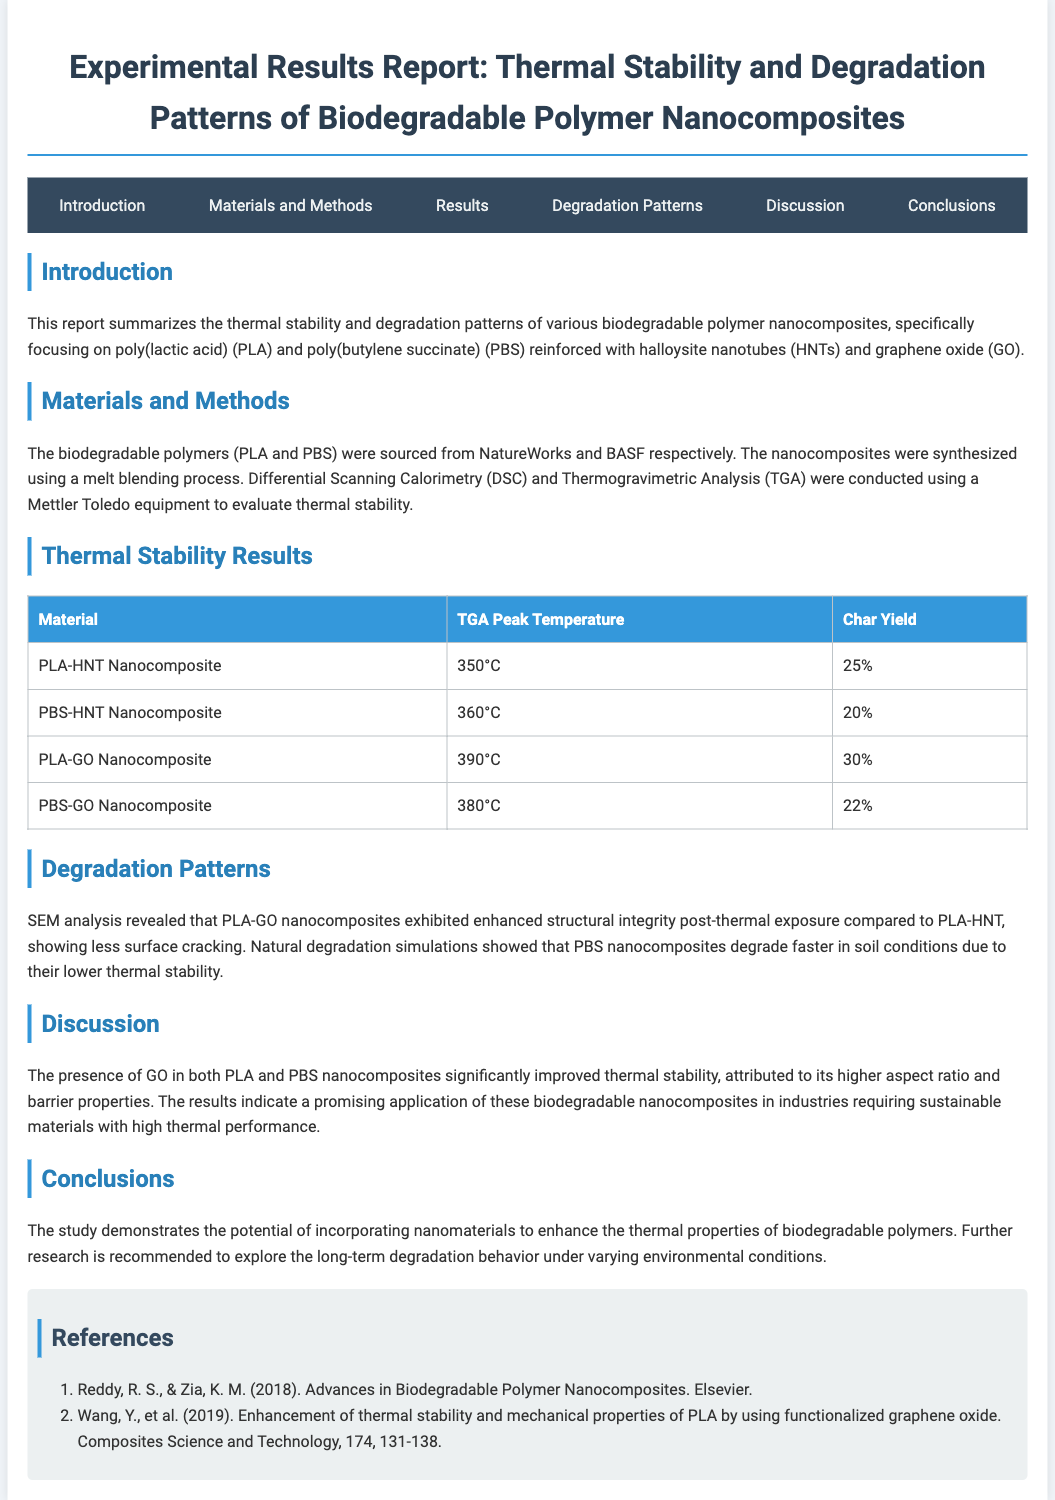What is the title of the report? The title is prominently displayed at the top of the document, summarizing the key focus of the study.
Answer: Experimental Results Report: Thermal Stability and Degradation Patterns of Biodegradable Polymer Nanocomposites What polymers are studied in the report? The document specifically mentions the biodegradable polymers being investigated, which are highlighted in the introduction.
Answer: PLA and PBS What is the TGA Peak Temperature for PLA-GO Nanocomposite? The TGA peak temperatures are provided in a table under thermal stability results, providing specific values for each nanocomposite.
Answer: 390°C What is the Char Yield for PBS-HNT Nanocomposite? The char yields for different nanocomposites are listed in the same table, indicating how much material remains after degradation.
Answer: 20% Which nanocomposite exhibited better structural integrity post-thermal exposure? This information is derived from the degradation patterns section, where comparisons between nanocomposites are discussed.
Answer: PLA-GO What analytical techniques were used to evaluate thermal stability? The document outlines the specific methods applied for thermal analysis in the materials and methods section.
Answer: DSC and TGA In which section is the discussion regarding the presence of GO found? The content organization of the document helps in identifying where specific discussions are located, aiding comprehension of the thermal stability improvements.
Answer: Discussion What recommendation is made for future research? The conclusions section summarizes the findings and suggests further inquiry areas based on observed results.
Answer: Long-term degradation behavior under varying environmental conditions 